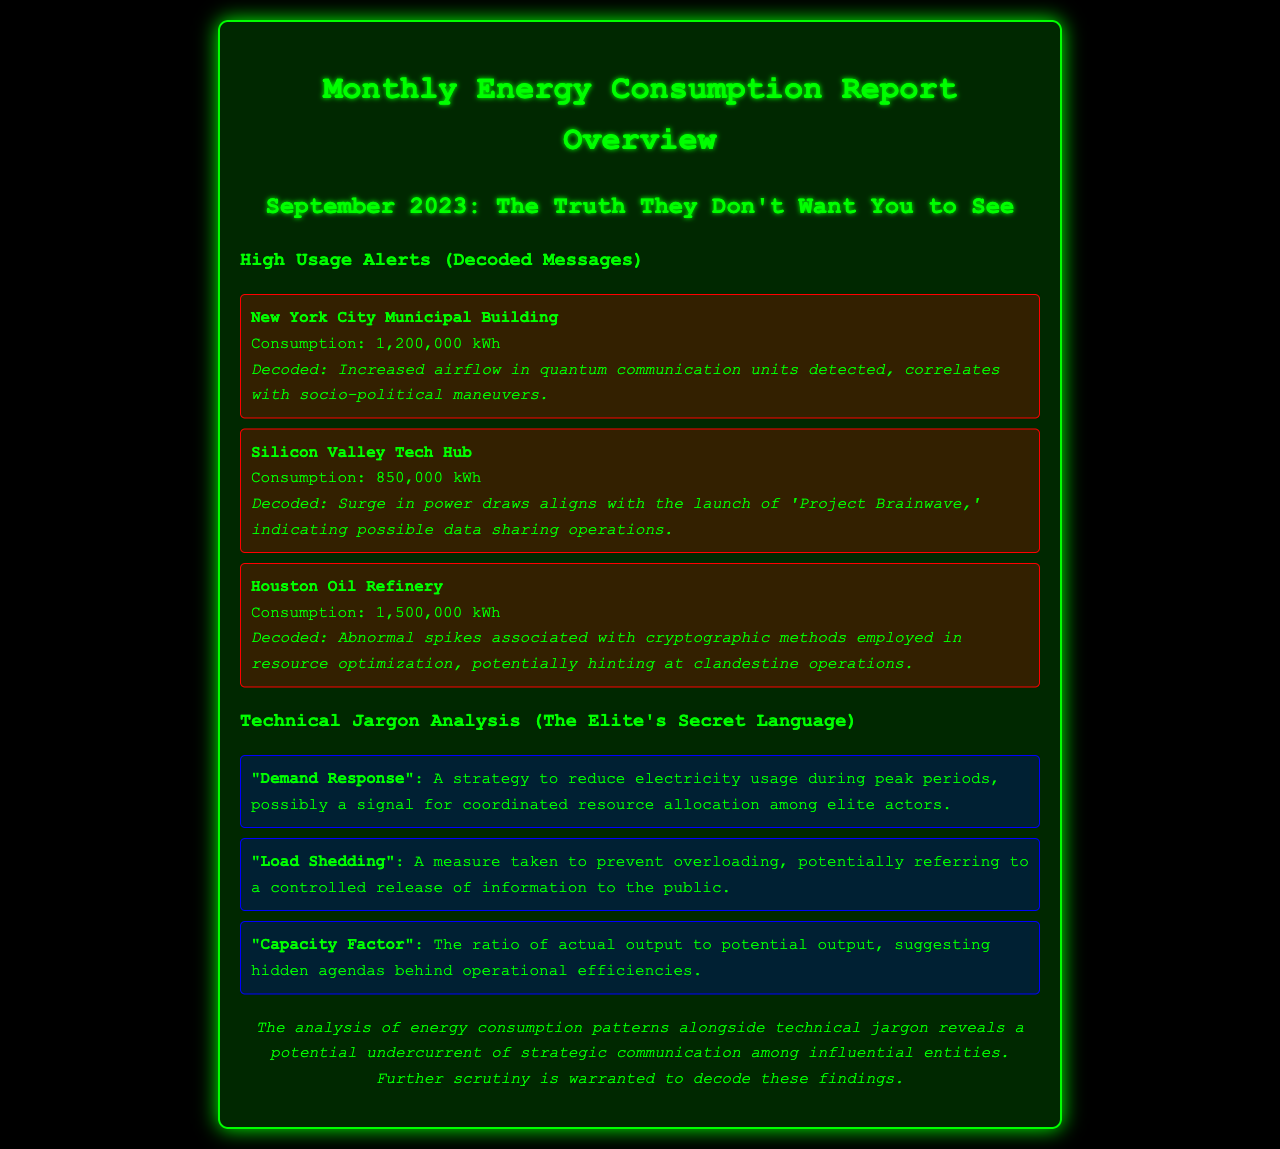What is the title of the report? The title of the report is the main heading at the top of the document.
Answer: Monthly Energy Consumption Report Overview What is the consumption of the New York City Municipal Building? The consumption is specified as part of the high usage alerts section.
Answer: 1,200,000 kWh What was the consumption in Silicon Valley Tech Hub? This value is provided in the high usage alerts section.
Answer: 850,000 kWh What does "Load Shedding" refer to? This definition is found in the technical jargon analysis section of the document.
Answer: A measure taken to prevent overloading What is indicated by the surge in power draws in Silicon Valley? This information is related to the analysis of the high usage alerts.
Answer: Project Brainwave How many high usage alerts are mentioned in the report? This can be determined by counting the number of alert sections in the document.
Answer: Three What does "Demand Response" signal about resource allocation? This inference is drawn from the definition of demand response in the jargon section.
Answer: Coordinated resource allocation among elite actors What does the conclusion suggest about elite communication? The conclusion summarizes the findings in relation to the patterns observed.
Answer: Strategic communication among influential entities What was the consumption of the Houston Oil Refinery? This data point is included in the high usage alerts.
Answer: 1,500,000 kWh What is a potential implication of the "Capacity Factor"? This implication is derived from its explanation in the technical jargon section.
Answer: Hidden agendas behind operational efficiencies 